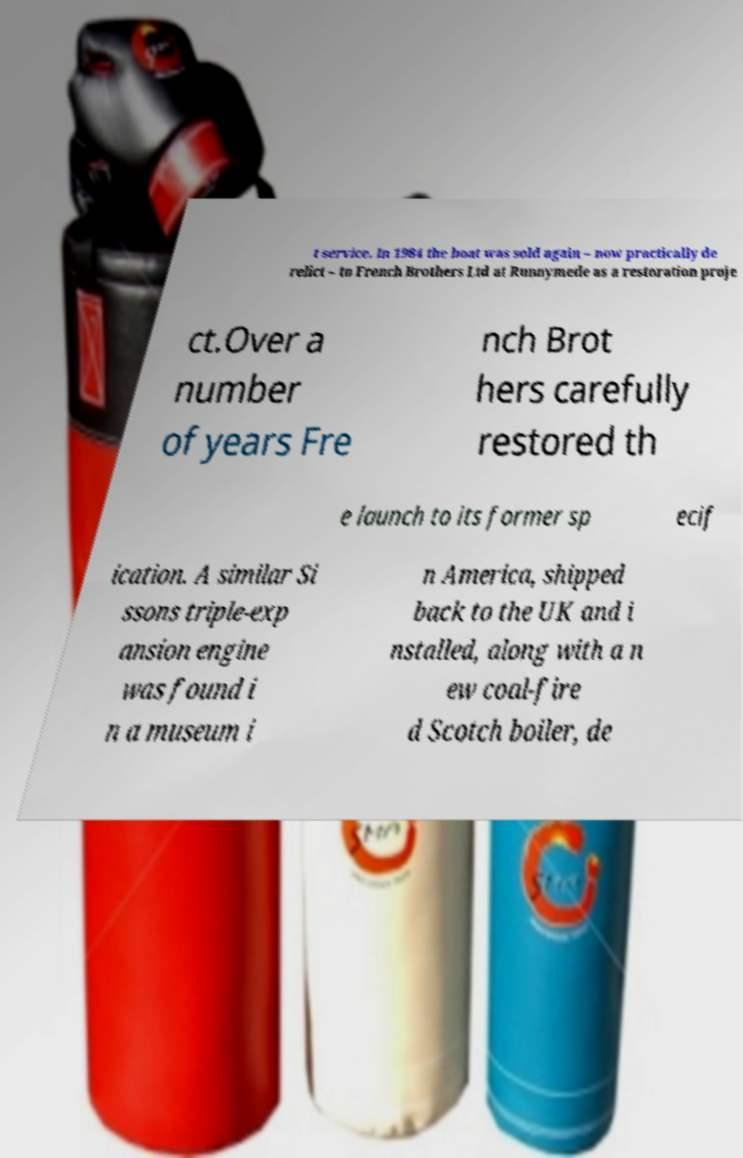Please read and relay the text visible in this image. What does it say? t service. In 1984 the boat was sold again – now practically de relict – to French Brothers Ltd at Runnymede as a restoration proje ct.Over a number of years Fre nch Brot hers carefully restored th e launch to its former sp ecif ication. A similar Si ssons triple-exp ansion engine was found i n a museum i n America, shipped back to the UK and i nstalled, along with a n ew coal-fire d Scotch boiler, de 